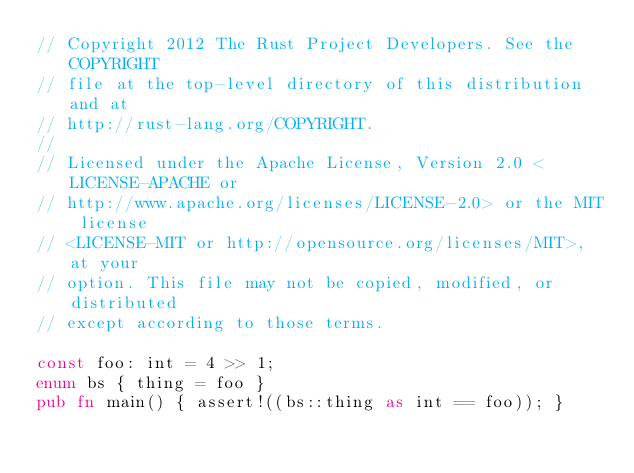<code> <loc_0><loc_0><loc_500><loc_500><_Rust_>// Copyright 2012 The Rust Project Developers. See the COPYRIGHT
// file at the top-level directory of this distribution and at
// http://rust-lang.org/COPYRIGHT.
//
// Licensed under the Apache License, Version 2.0 <LICENSE-APACHE or
// http://www.apache.org/licenses/LICENSE-2.0> or the MIT license
// <LICENSE-MIT or http://opensource.org/licenses/MIT>, at your
// option. This file may not be copied, modified, or distributed
// except according to those terms.

const foo: int = 4 >> 1;
enum bs { thing = foo }
pub fn main() { assert!((bs::thing as int == foo)); }
</code> 